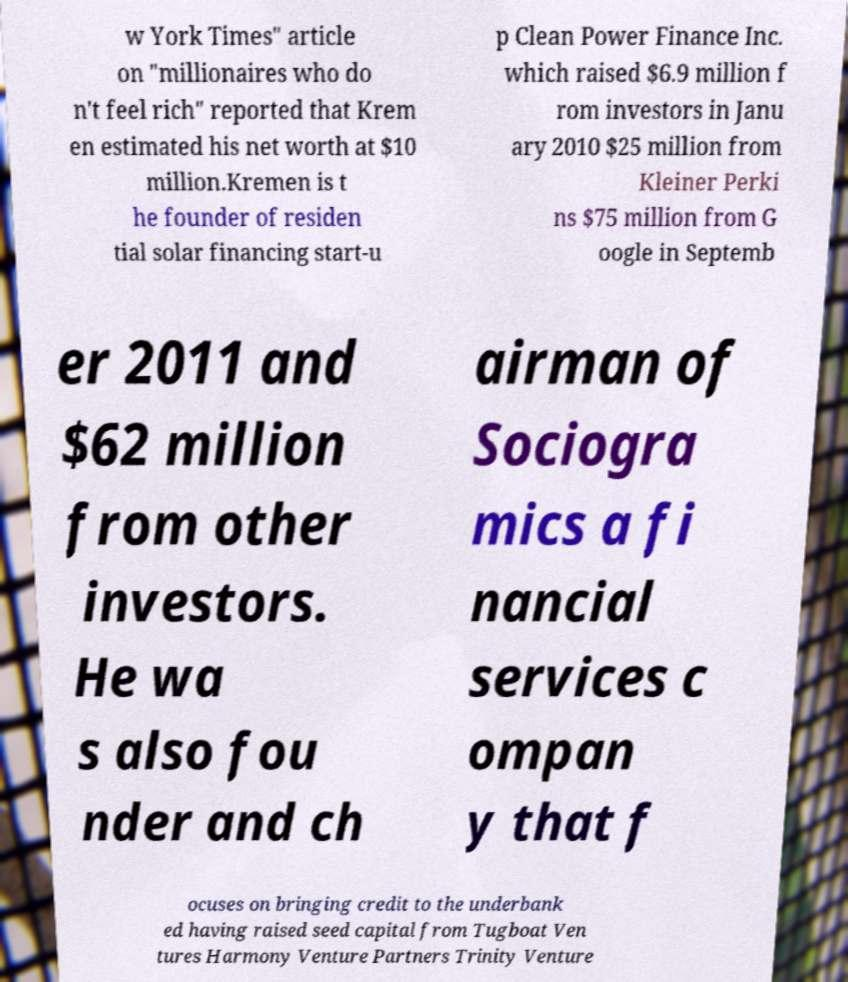Please identify and transcribe the text found in this image. w York Times" article on "millionaires who do n't feel rich" reported that Krem en estimated his net worth at $10 million.Kremen is t he founder of residen tial solar financing start-u p Clean Power Finance Inc. which raised $6.9 million f rom investors in Janu ary 2010 $25 million from Kleiner Perki ns $75 million from G oogle in Septemb er 2011 and $62 million from other investors. He wa s also fou nder and ch airman of Sociogra mics a fi nancial services c ompan y that f ocuses on bringing credit to the underbank ed having raised seed capital from Tugboat Ven tures Harmony Venture Partners Trinity Venture 